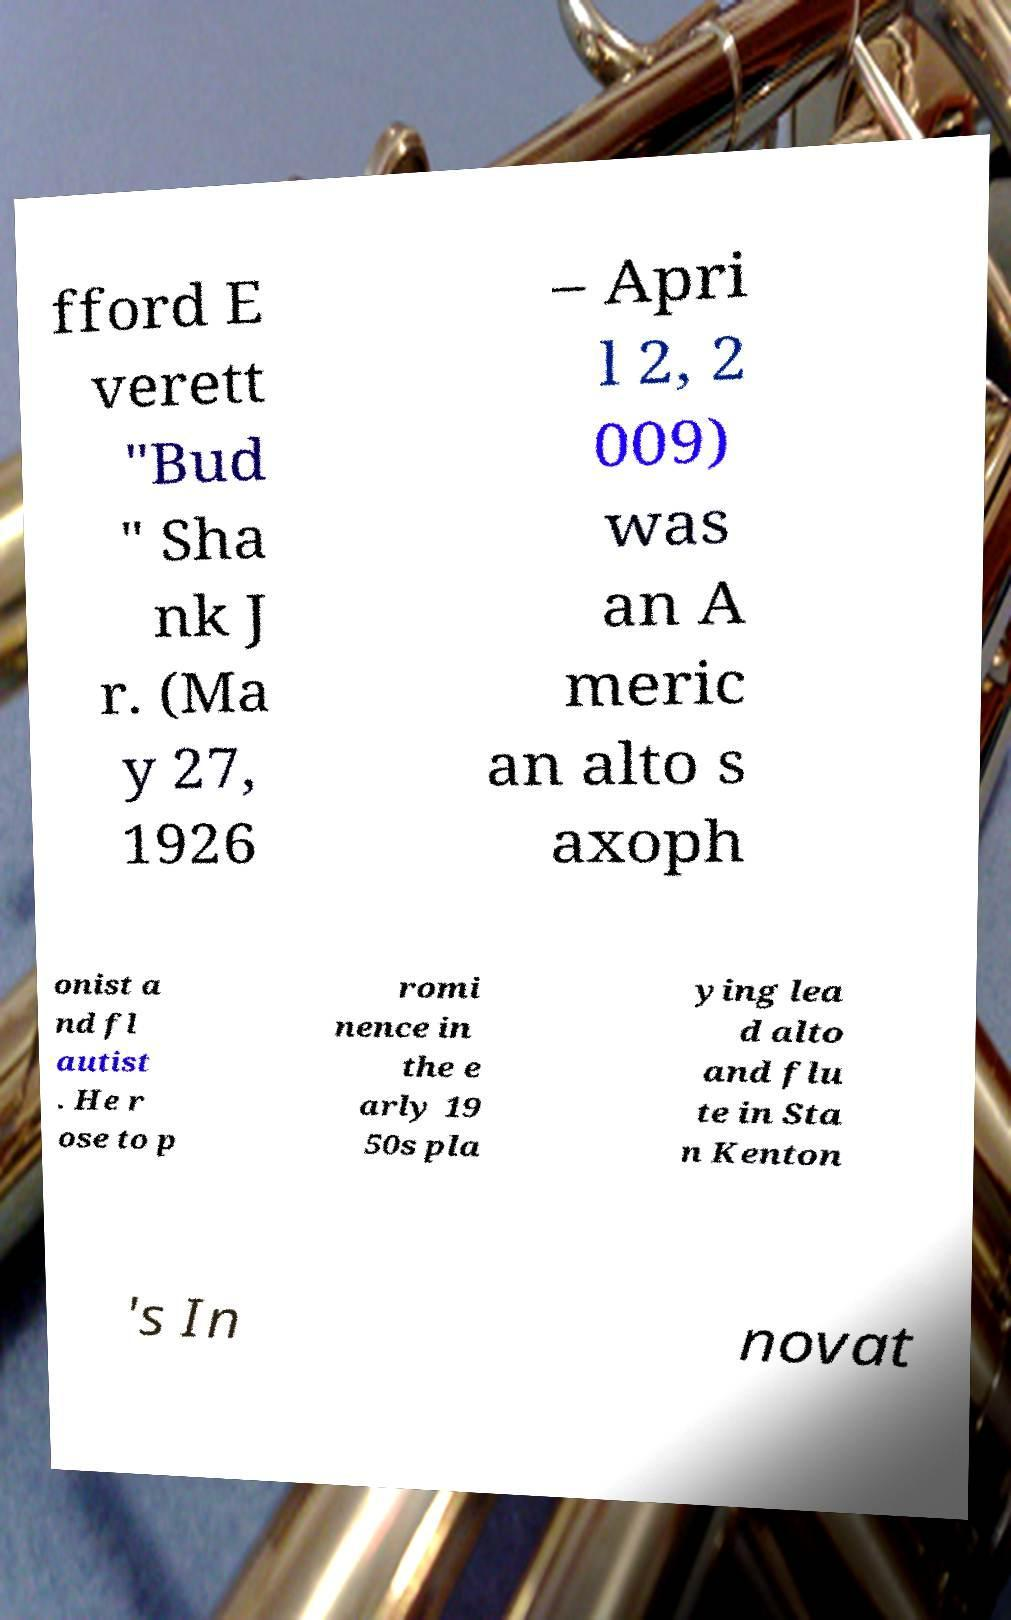Could you extract and type out the text from this image? fford E verett "Bud " Sha nk J r. (Ma y 27, 1926 – Apri l 2, 2 009) was an A meric an alto s axoph onist a nd fl autist . He r ose to p romi nence in the e arly 19 50s pla ying lea d alto and flu te in Sta n Kenton 's In novat 